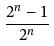<formula> <loc_0><loc_0><loc_500><loc_500>\frac { 2 ^ { n } - 1 } { 2 ^ { n } }</formula> 